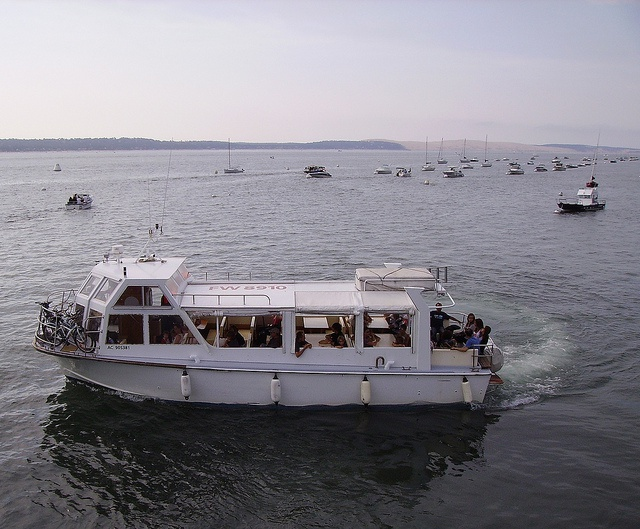Describe the objects in this image and their specific colors. I can see boat in lavender, gray, darkgray, black, and lightgray tones, boat in lavender, darkgray, gray, and black tones, bicycle in lavender, black, gray, and darkgray tones, boat in lavender, black, darkgray, gray, and lightgray tones, and people in lavender, black, gray, and darkgray tones in this image. 